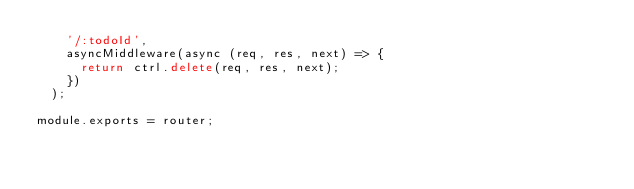Convert code to text. <code><loc_0><loc_0><loc_500><loc_500><_JavaScript_>    '/:todoId',
    asyncMiddleware(async (req, res, next) => {
      return ctrl.delete(req, res, next);
    })
  );

module.exports = router;
</code> 